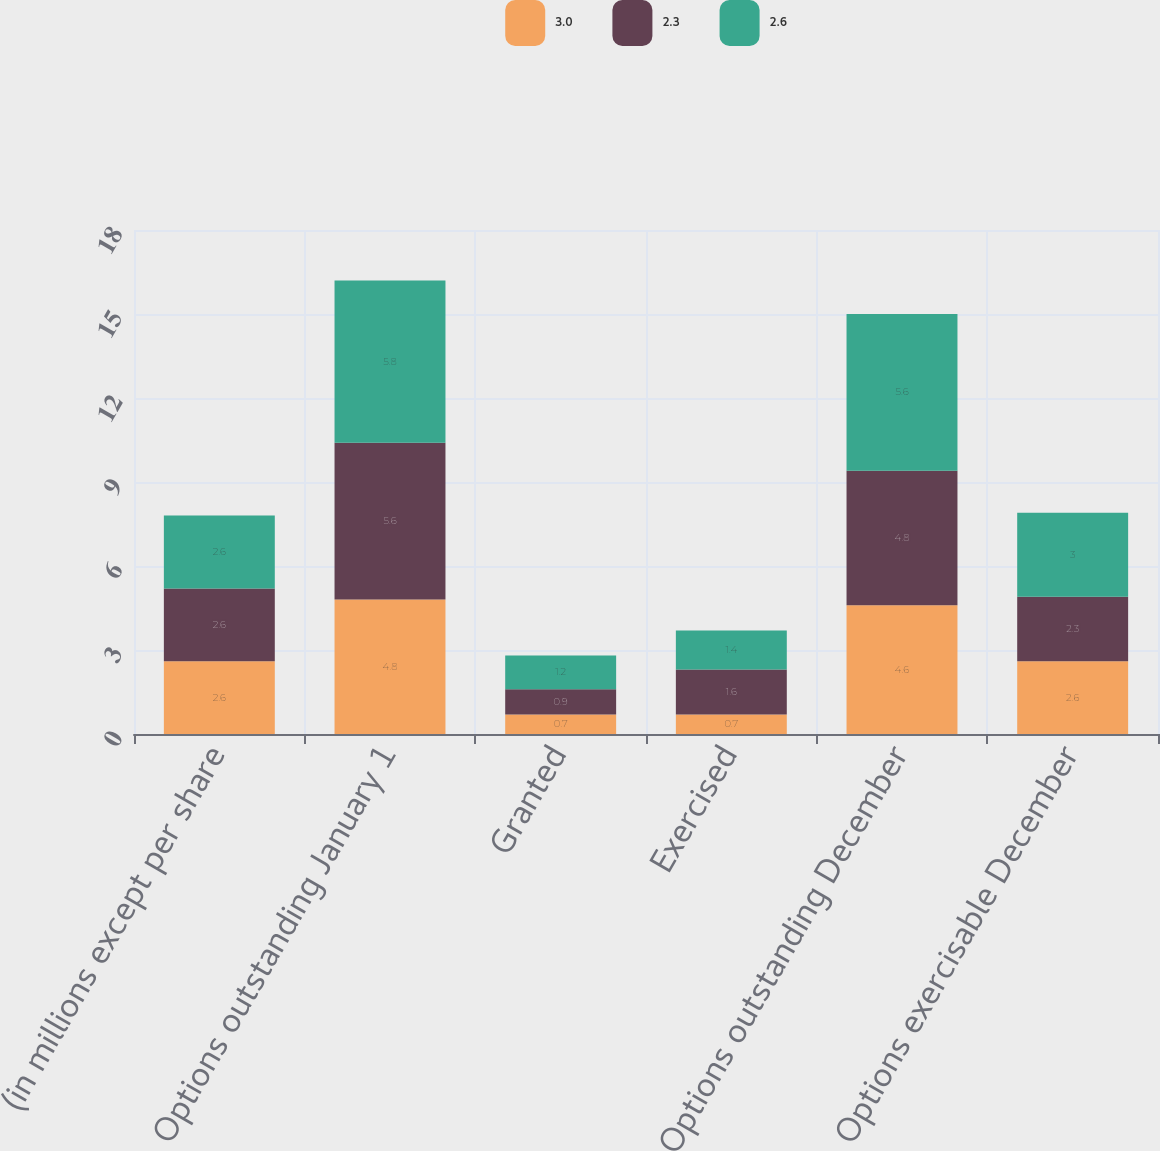Convert chart. <chart><loc_0><loc_0><loc_500><loc_500><stacked_bar_chart><ecel><fcel>(in millions except per share<fcel>Options outstanding January 1<fcel>Granted<fcel>Exercised<fcel>Options outstanding December<fcel>Options exercisable December<nl><fcel>3<fcel>2.6<fcel>4.8<fcel>0.7<fcel>0.7<fcel>4.6<fcel>2.6<nl><fcel>2.3<fcel>2.6<fcel>5.6<fcel>0.9<fcel>1.6<fcel>4.8<fcel>2.3<nl><fcel>2.6<fcel>2.6<fcel>5.8<fcel>1.2<fcel>1.4<fcel>5.6<fcel>3<nl></chart> 